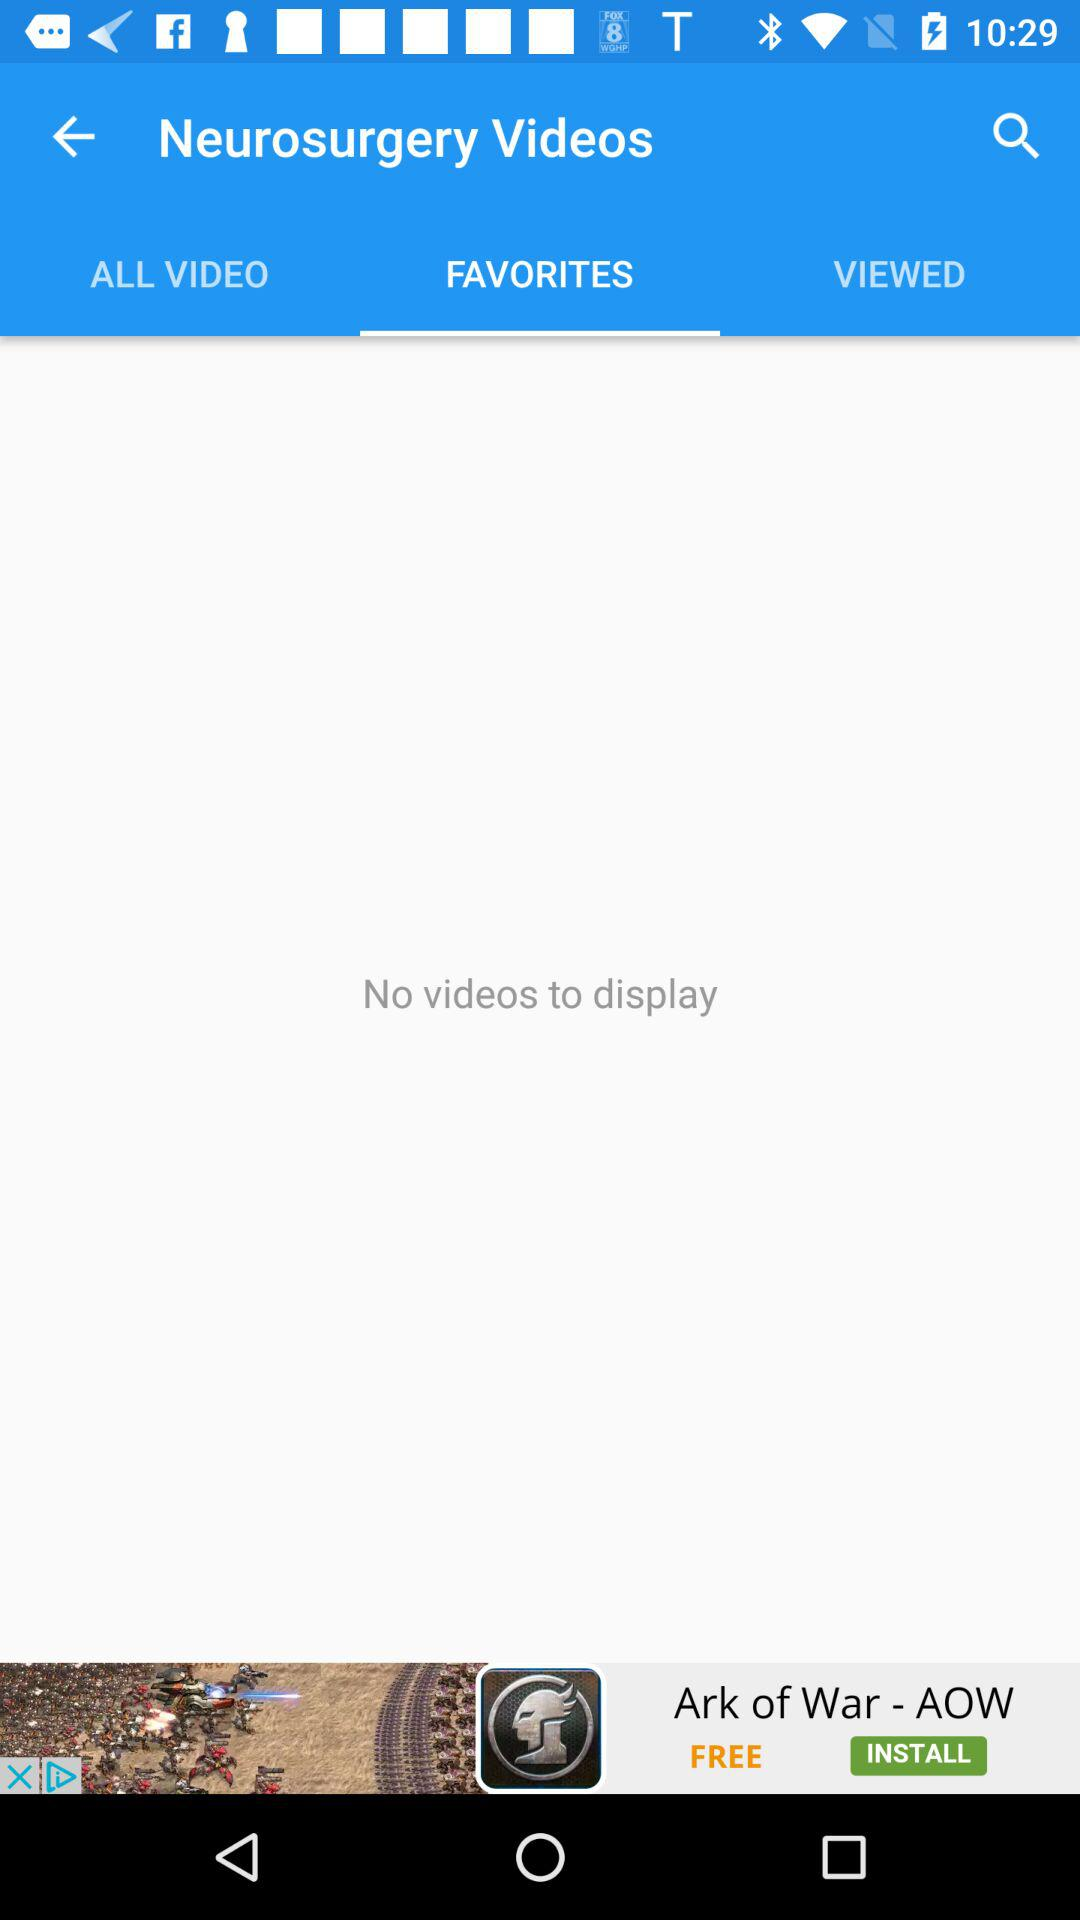When was the last video viewed?
When the provided information is insufficient, respond with <no answer>. <no answer> 